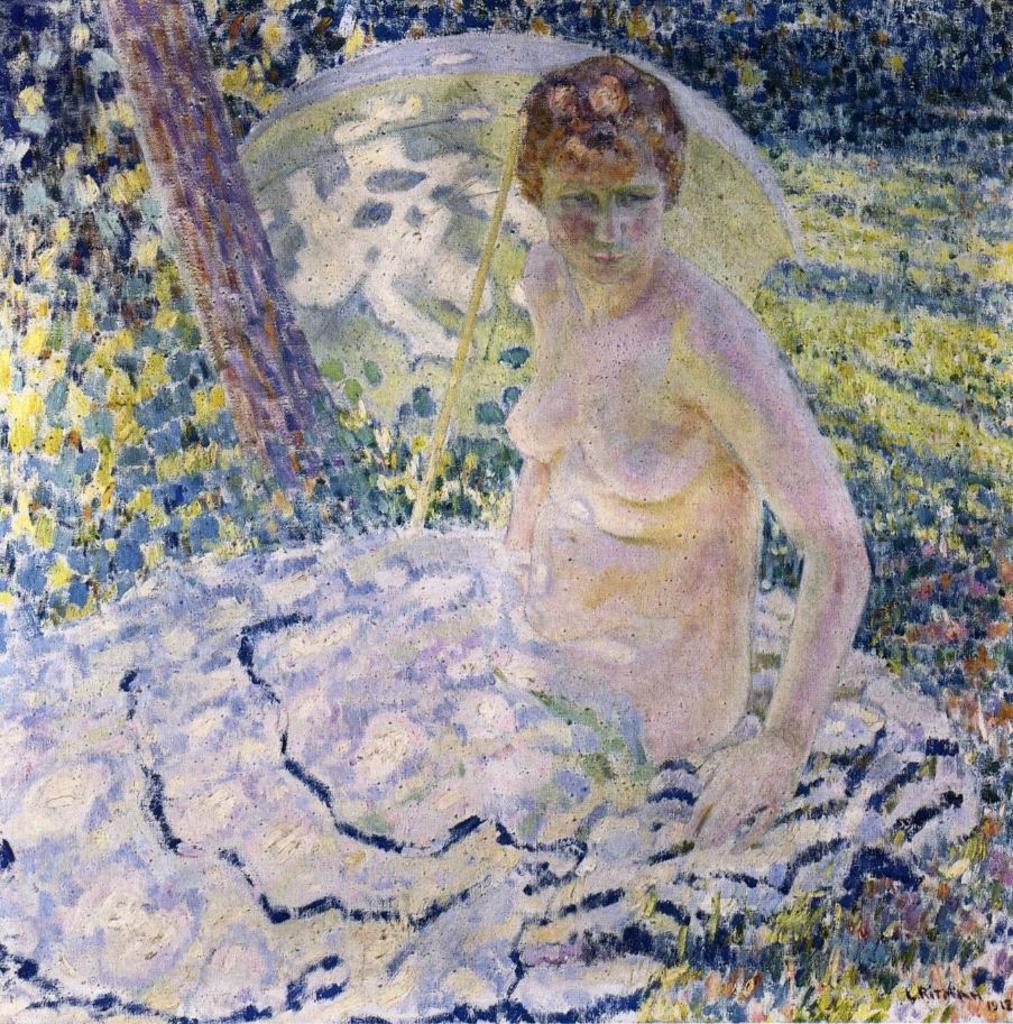Please provide a concise description of this image. This is a painting. In this picture we can see a person, an umbrella and a tree trunk. We can see some greenery in the background. There is some text visible in the bottom right. 